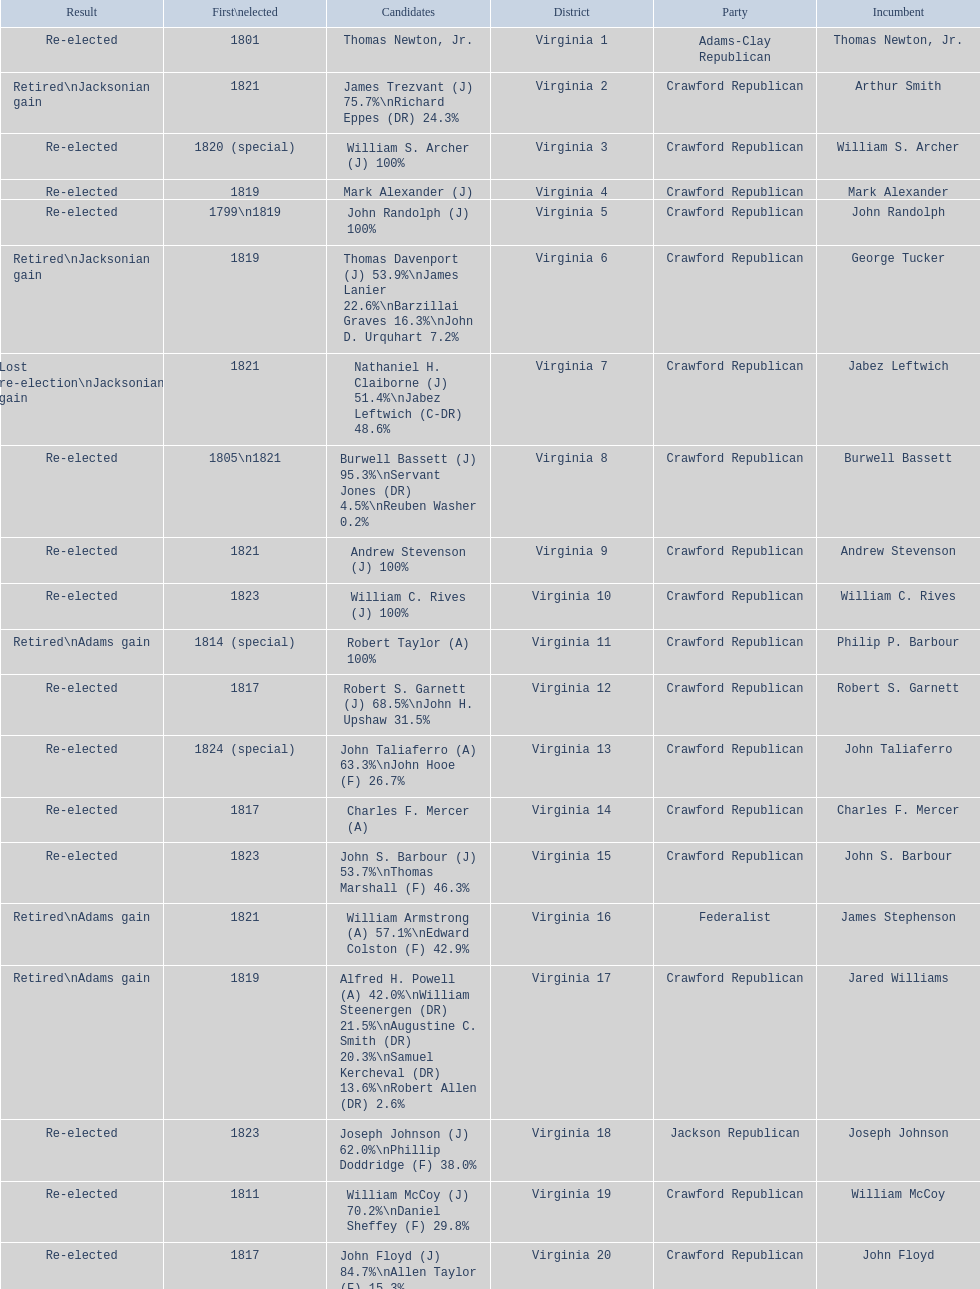Number of incumbents who retired or lost re-election 7. 